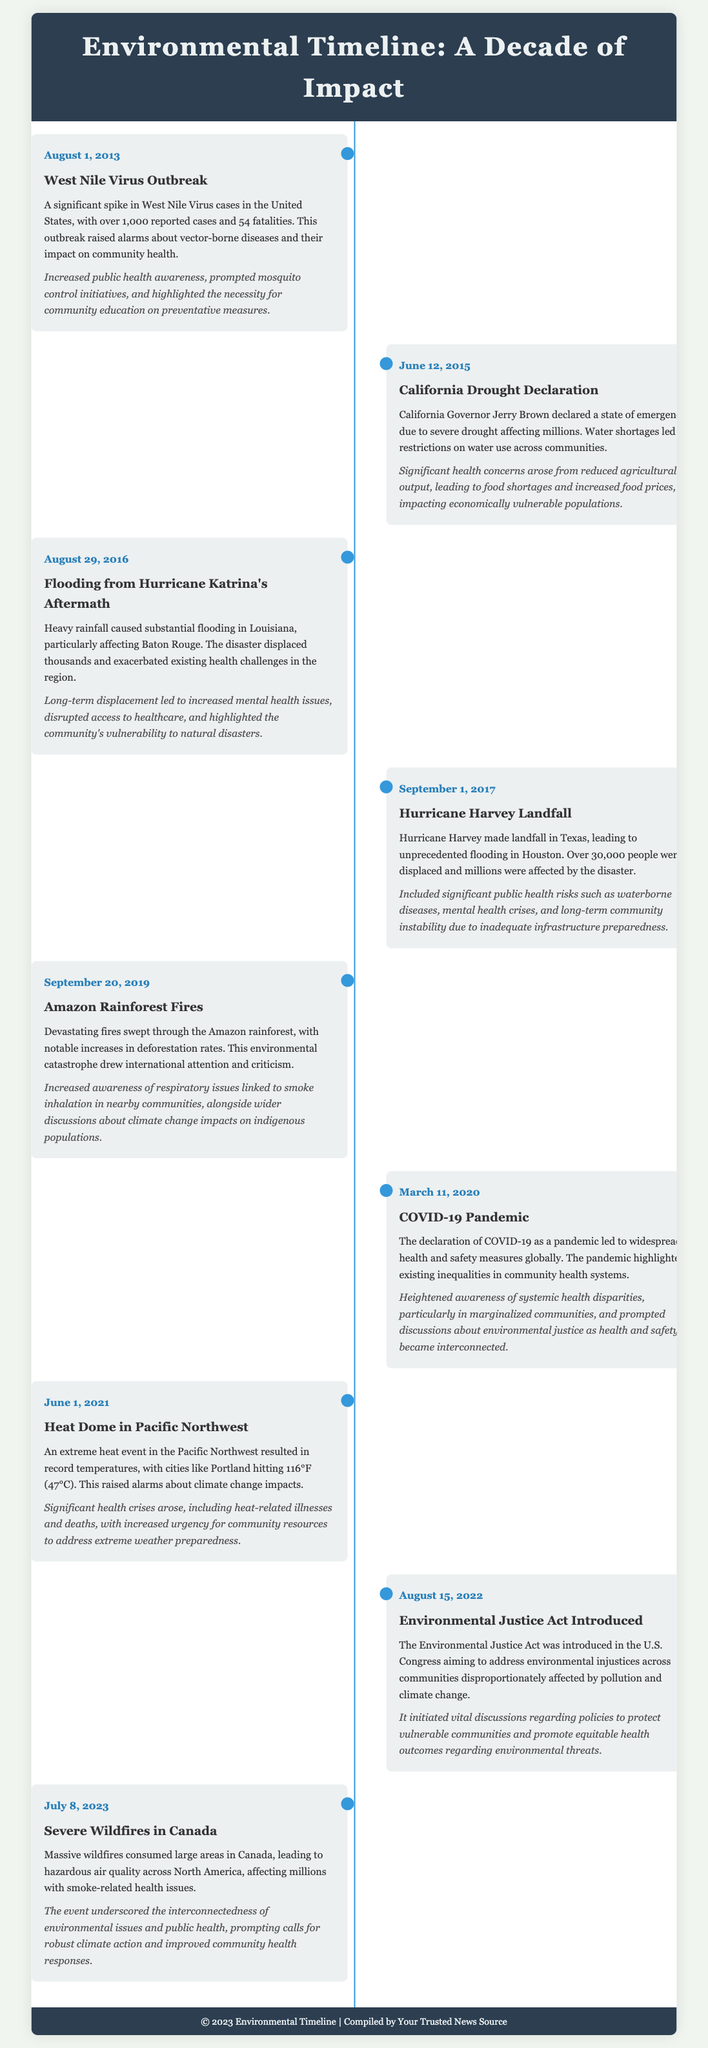what event occurred on August 1, 2013? The event dated August 1, 2013, is a significant spike in West Nile Virus cases in the United States.
Answer: West Nile Virus Outbreak how many fatalities were reported during the West Nile Virus outbreak? The document states there were 54 fatalities reported during the outbreak.
Answer: 54 what was declared on June 12, 2015? The document details that California Governor Jerry Brown declared a state of emergency due to severe drought.
Answer: California Drought Declaration which hurricane made landfall in Texas on September 1, 2017? According to the timeline, Hurricane Harvey made landfall in Texas on this date.
Answer: Hurricane Harvey what health issues arose from the Amazon rainforest fires? The event prompted increased awareness of respiratory issues linked to smoke inhalation in nearby communities.
Answer: Respiratory issues what legislation aimed at addressing environmental injustices was introduced on August 15, 2022? The document mentions the introduction of the Environmental Justice Act in U.S. Congress.
Answer: Environmental Justice Act how did the COVID-19 pandemic highlight community health systems? The pandemic highlighted existing inequalities in community health systems according to the document.
Answer: Existing inequalities how did the severe wildfires in Canada affect air quality? The wildfires led to hazardous air quality across North America affecting millions.
Answer: Hazardous air quality 